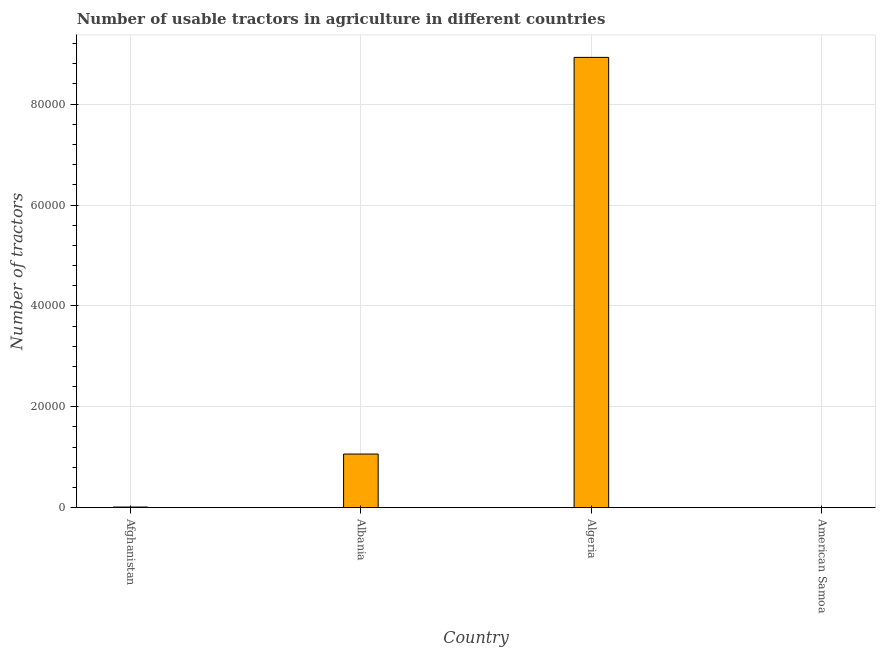What is the title of the graph?
Offer a very short reply. Number of usable tractors in agriculture in different countries. What is the label or title of the X-axis?
Make the answer very short. Country. What is the label or title of the Y-axis?
Your response must be concise. Number of tractors. What is the number of tractors in Albania?
Your answer should be compact. 1.06e+04. Across all countries, what is the maximum number of tractors?
Ensure brevity in your answer.  8.93e+04. Across all countries, what is the minimum number of tractors?
Your answer should be very brief. 11. In which country was the number of tractors maximum?
Provide a succinct answer. Algeria. In which country was the number of tractors minimum?
Your answer should be compact. American Samoa. What is the sum of the number of tractors?
Make the answer very short. 1.00e+05. What is the difference between the number of tractors in Albania and American Samoa?
Ensure brevity in your answer.  1.06e+04. What is the average number of tractors per country?
Offer a terse response. 2.50e+04. What is the median number of tractors?
Your response must be concise. 5375. Is the number of tractors in Algeria less than that in American Samoa?
Make the answer very short. No. What is the difference between the highest and the second highest number of tractors?
Your answer should be very brief. 7.86e+04. What is the difference between the highest and the lowest number of tractors?
Provide a short and direct response. 8.93e+04. In how many countries, is the number of tractors greater than the average number of tractors taken over all countries?
Your response must be concise. 1. Are all the bars in the graph horizontal?
Your answer should be very brief. No. How many countries are there in the graph?
Your answer should be compact. 4. What is the difference between two consecutive major ticks on the Y-axis?
Provide a short and direct response. 2.00e+04. Are the values on the major ticks of Y-axis written in scientific E-notation?
Your response must be concise. No. What is the Number of tractors in Afghanistan?
Keep it short and to the point. 120. What is the Number of tractors of Albania?
Your answer should be very brief. 1.06e+04. What is the Number of tractors of Algeria?
Provide a succinct answer. 8.93e+04. What is the Number of tractors in American Samoa?
Provide a short and direct response. 11. What is the difference between the Number of tractors in Afghanistan and Albania?
Give a very brief answer. -1.05e+04. What is the difference between the Number of tractors in Afghanistan and Algeria?
Give a very brief answer. -8.92e+04. What is the difference between the Number of tractors in Afghanistan and American Samoa?
Keep it short and to the point. 109. What is the difference between the Number of tractors in Albania and Algeria?
Offer a terse response. -7.86e+04. What is the difference between the Number of tractors in Albania and American Samoa?
Your response must be concise. 1.06e+04. What is the difference between the Number of tractors in Algeria and American Samoa?
Your answer should be very brief. 8.93e+04. What is the ratio of the Number of tractors in Afghanistan to that in Albania?
Your answer should be very brief. 0.01. What is the ratio of the Number of tractors in Afghanistan to that in Algeria?
Give a very brief answer. 0. What is the ratio of the Number of tractors in Afghanistan to that in American Samoa?
Ensure brevity in your answer.  10.91. What is the ratio of the Number of tractors in Albania to that in Algeria?
Offer a very short reply. 0.12. What is the ratio of the Number of tractors in Albania to that in American Samoa?
Your response must be concise. 966.36. What is the ratio of the Number of tractors in Algeria to that in American Samoa?
Ensure brevity in your answer.  8115.55. 